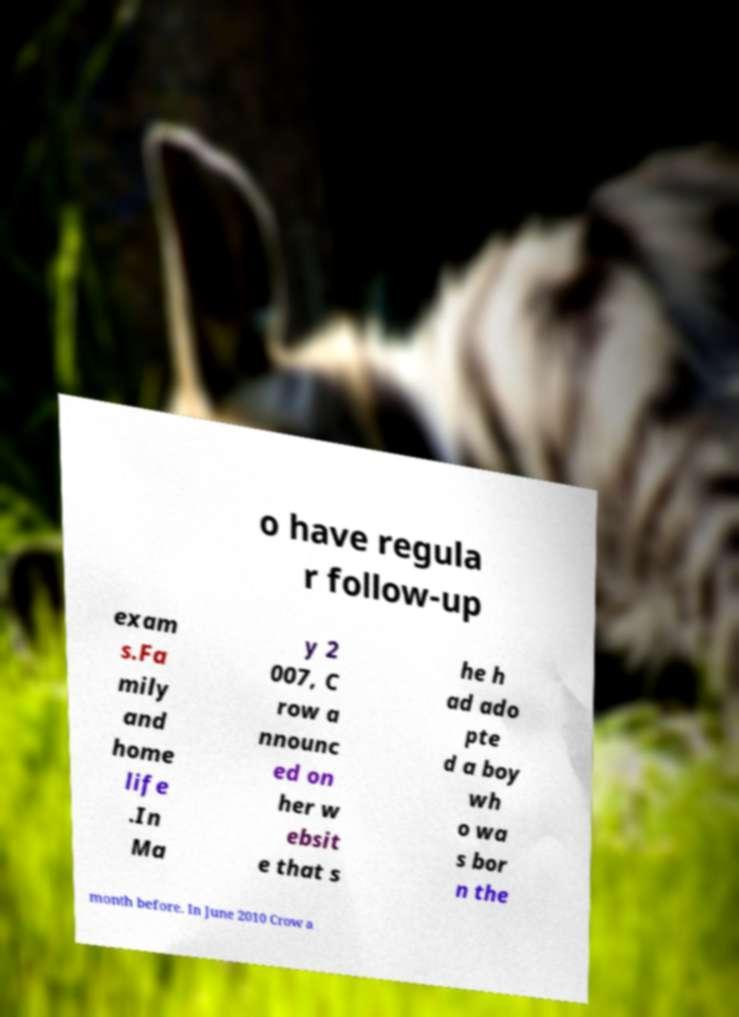For documentation purposes, I need the text within this image transcribed. Could you provide that? o have regula r follow-up exam s.Fa mily and home life .In Ma y 2 007, C row a nnounc ed on her w ebsit e that s he h ad ado pte d a boy wh o wa s bor n the month before. In June 2010 Crow a 